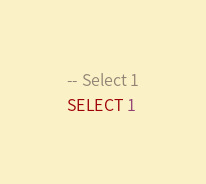Convert code to text. <code><loc_0><loc_0><loc_500><loc_500><_SQL_>-- Select 1
SELECT 1
</code> 